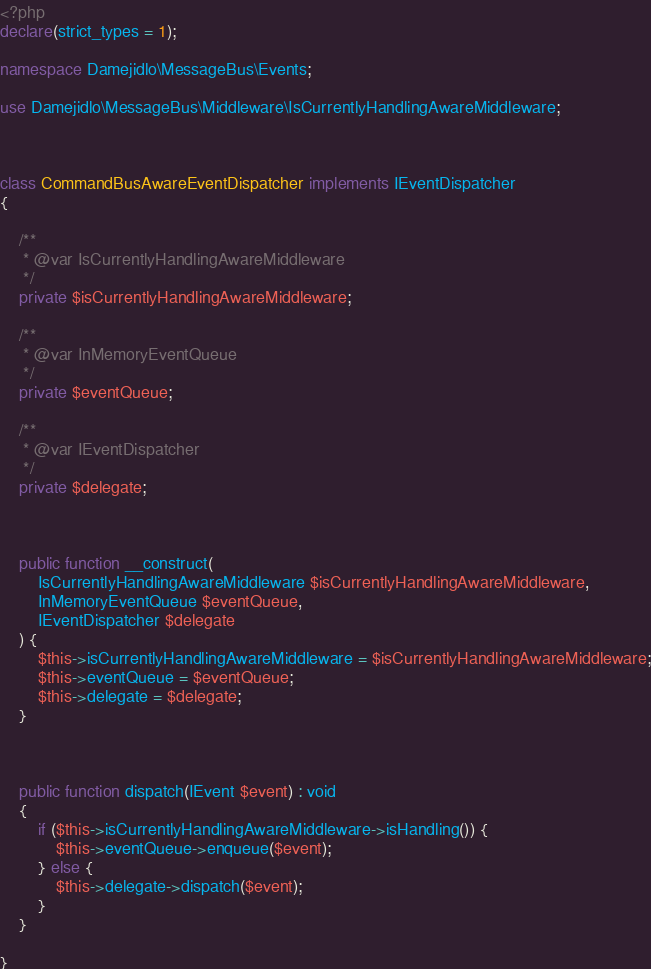Convert code to text. <code><loc_0><loc_0><loc_500><loc_500><_PHP_><?php
declare(strict_types = 1);

namespace Damejidlo\MessageBus\Events;

use Damejidlo\MessageBus\Middleware\IsCurrentlyHandlingAwareMiddleware;



class CommandBusAwareEventDispatcher implements IEventDispatcher
{

	/**
	 * @var IsCurrentlyHandlingAwareMiddleware
	 */
	private $isCurrentlyHandlingAwareMiddleware;

	/**
	 * @var InMemoryEventQueue
	 */
	private $eventQueue;

	/**
	 * @var IEventDispatcher
	 */
	private $delegate;



	public function __construct(
		IsCurrentlyHandlingAwareMiddleware $isCurrentlyHandlingAwareMiddleware,
		InMemoryEventQueue $eventQueue,
		IEventDispatcher $delegate
	) {
		$this->isCurrentlyHandlingAwareMiddleware = $isCurrentlyHandlingAwareMiddleware;
		$this->eventQueue = $eventQueue;
		$this->delegate = $delegate;
	}



	public function dispatch(IEvent $event) : void
	{
		if ($this->isCurrentlyHandlingAwareMiddleware->isHandling()) {
			$this->eventQueue->enqueue($event);
		} else {
			$this->delegate->dispatch($event);
		}
	}

}
</code> 